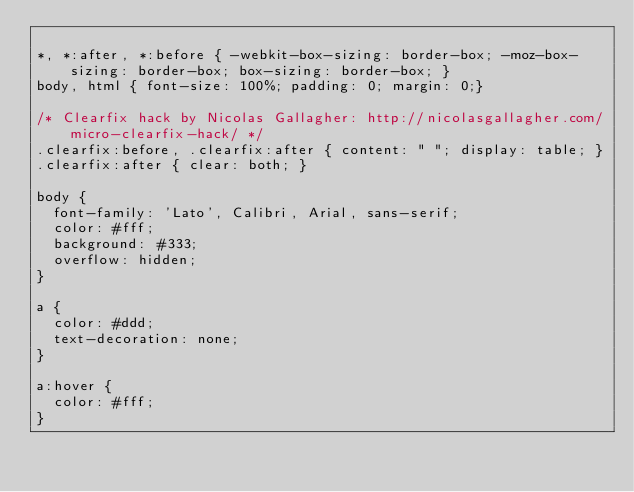Convert code to text. <code><loc_0><loc_0><loc_500><loc_500><_CSS_>
*, *:after, *:before { -webkit-box-sizing: border-box; -moz-box-sizing: border-box; box-sizing: border-box; }
body, html { font-size: 100%; padding: 0; margin: 0;}

/* Clearfix hack by Nicolas Gallagher: http://nicolasgallagher.com/micro-clearfix-hack/ */
.clearfix:before, .clearfix:after { content: " "; display: table; }
.clearfix:after { clear: both; }

body {
  font-family: 'Lato', Calibri, Arial, sans-serif;
  color: #fff;
  background: #333;
  overflow: hidden;
}

a {
  color: #ddd;
  text-decoration: none;
}

a:hover {
  color: #fff;
}

</code> 